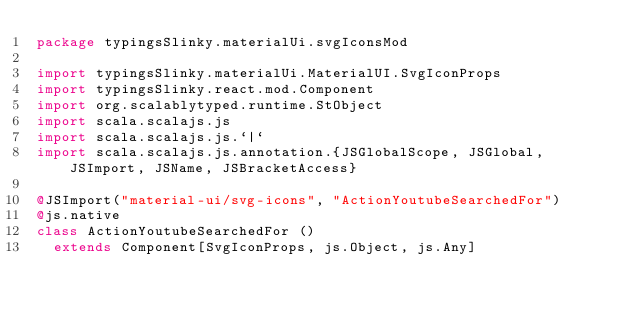Convert code to text. <code><loc_0><loc_0><loc_500><loc_500><_Scala_>package typingsSlinky.materialUi.svgIconsMod

import typingsSlinky.materialUi.MaterialUI.SvgIconProps
import typingsSlinky.react.mod.Component
import org.scalablytyped.runtime.StObject
import scala.scalajs.js
import scala.scalajs.js.`|`
import scala.scalajs.js.annotation.{JSGlobalScope, JSGlobal, JSImport, JSName, JSBracketAccess}

@JSImport("material-ui/svg-icons", "ActionYoutubeSearchedFor")
@js.native
class ActionYoutubeSearchedFor ()
  extends Component[SvgIconProps, js.Object, js.Any]
</code> 